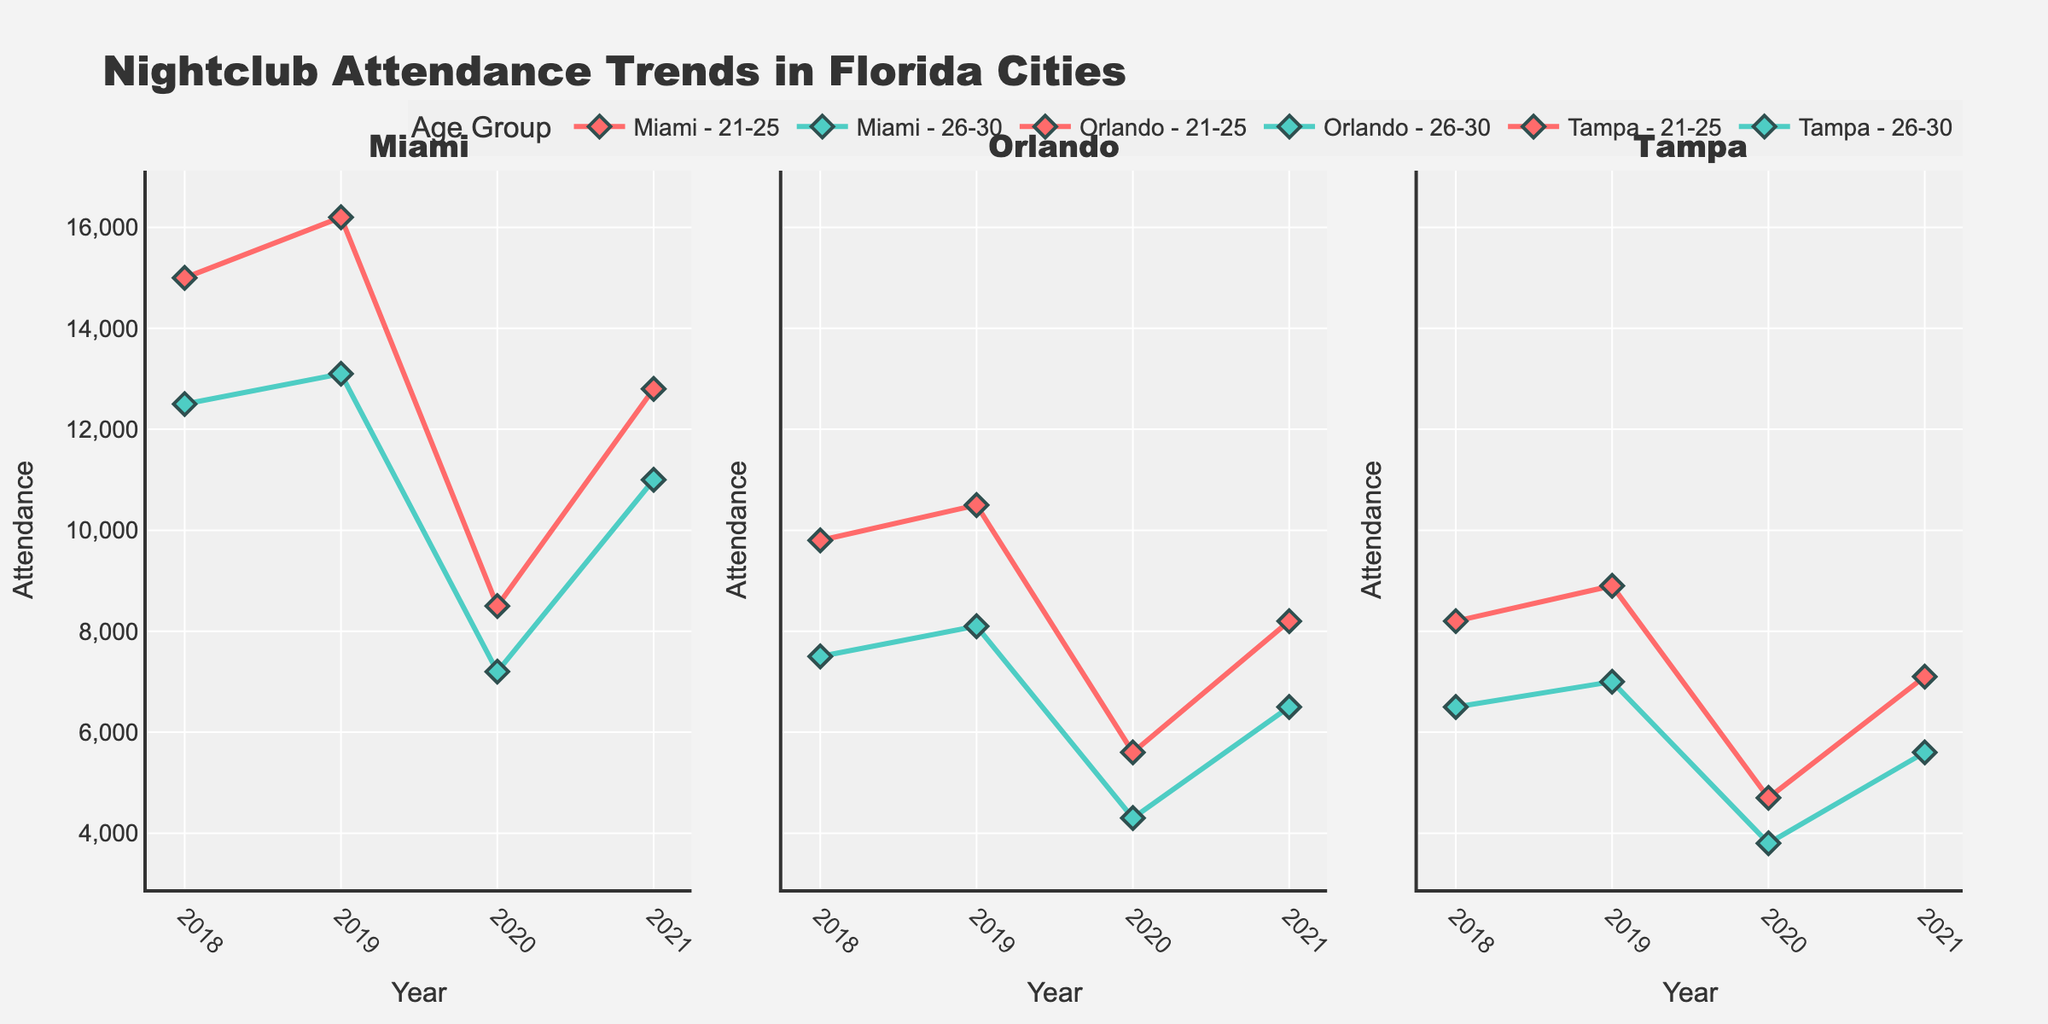Which city had the highest nightclub attendance in 2019 for the age group 21-25? To determine this, check the scatter plots for the year 2019 and observe the attendance values for each city in the age group 21-25. Miami has the highest value at 16,200 attendees.
Answer: Miami How did the night club attendance trend for the 26-30 age group in Tampa change from 2020 to 2021? Look at the scatter plot for Tampa and compare the attendance values for the 26-30 age group between these two years. Attendance increased from 3,800 in 2020 to 5,600 in 2021.
Answer: It increased Which city showed the least impact on nightclub attendance for the 21-25 age group between 2018 and 2021? Evaluate the changes in attendance for the age group 21-25 in all three cities over the mentioned years. Tampa's attendance drops from 8,200 to 7,100, which is less drastic compared to Miami and Orlando.
Answer: Tampa In which year did Orlando see the steepest decline in nightclub attendance for the 26-30 age group? Check the slope of the lines in the scatter plot for Orlando in the age group 26-30. The steepest decline happened between 2019 and 2020, dropping from 8,100 to 4,300.
Answer: 2020 Compare the nightclub attendance trends between the cities for the age group 21-25 in 2020. Which city had the highest decline? Observe the trend lines in the scatter plots for 2020 for each city. Compare the values of 2019 and 2020. Miami had the highest decline, dropping from 16,200 to 8,500.
Answer: Miami For the age group 26-30, which city had the lowest attendance in 2019 and what was the value? Check the scatter plots for the age group 26-30 in the year 2019. Tampa had the lowest attendance with 7,000 attendees.
Answer: Tampa, 7,000 Between 2018 and 2021, which age group in Miami showed a recovery in nightclub attendance after 2020? Look at the trends post-2020 in the scatter plot for Miami and evaluate how the attendance changes. Both age groups (21-25 and 26-30) show recovery, but 21-25 increased significantly from 8,500 in 2020 to 12,800 in 2021.
Answer: 21-25 